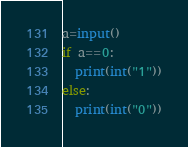<code> <loc_0><loc_0><loc_500><loc_500><_Python_>a=input()
if a==0:
  print(int("1"))
else:
  print(int("0"))</code> 